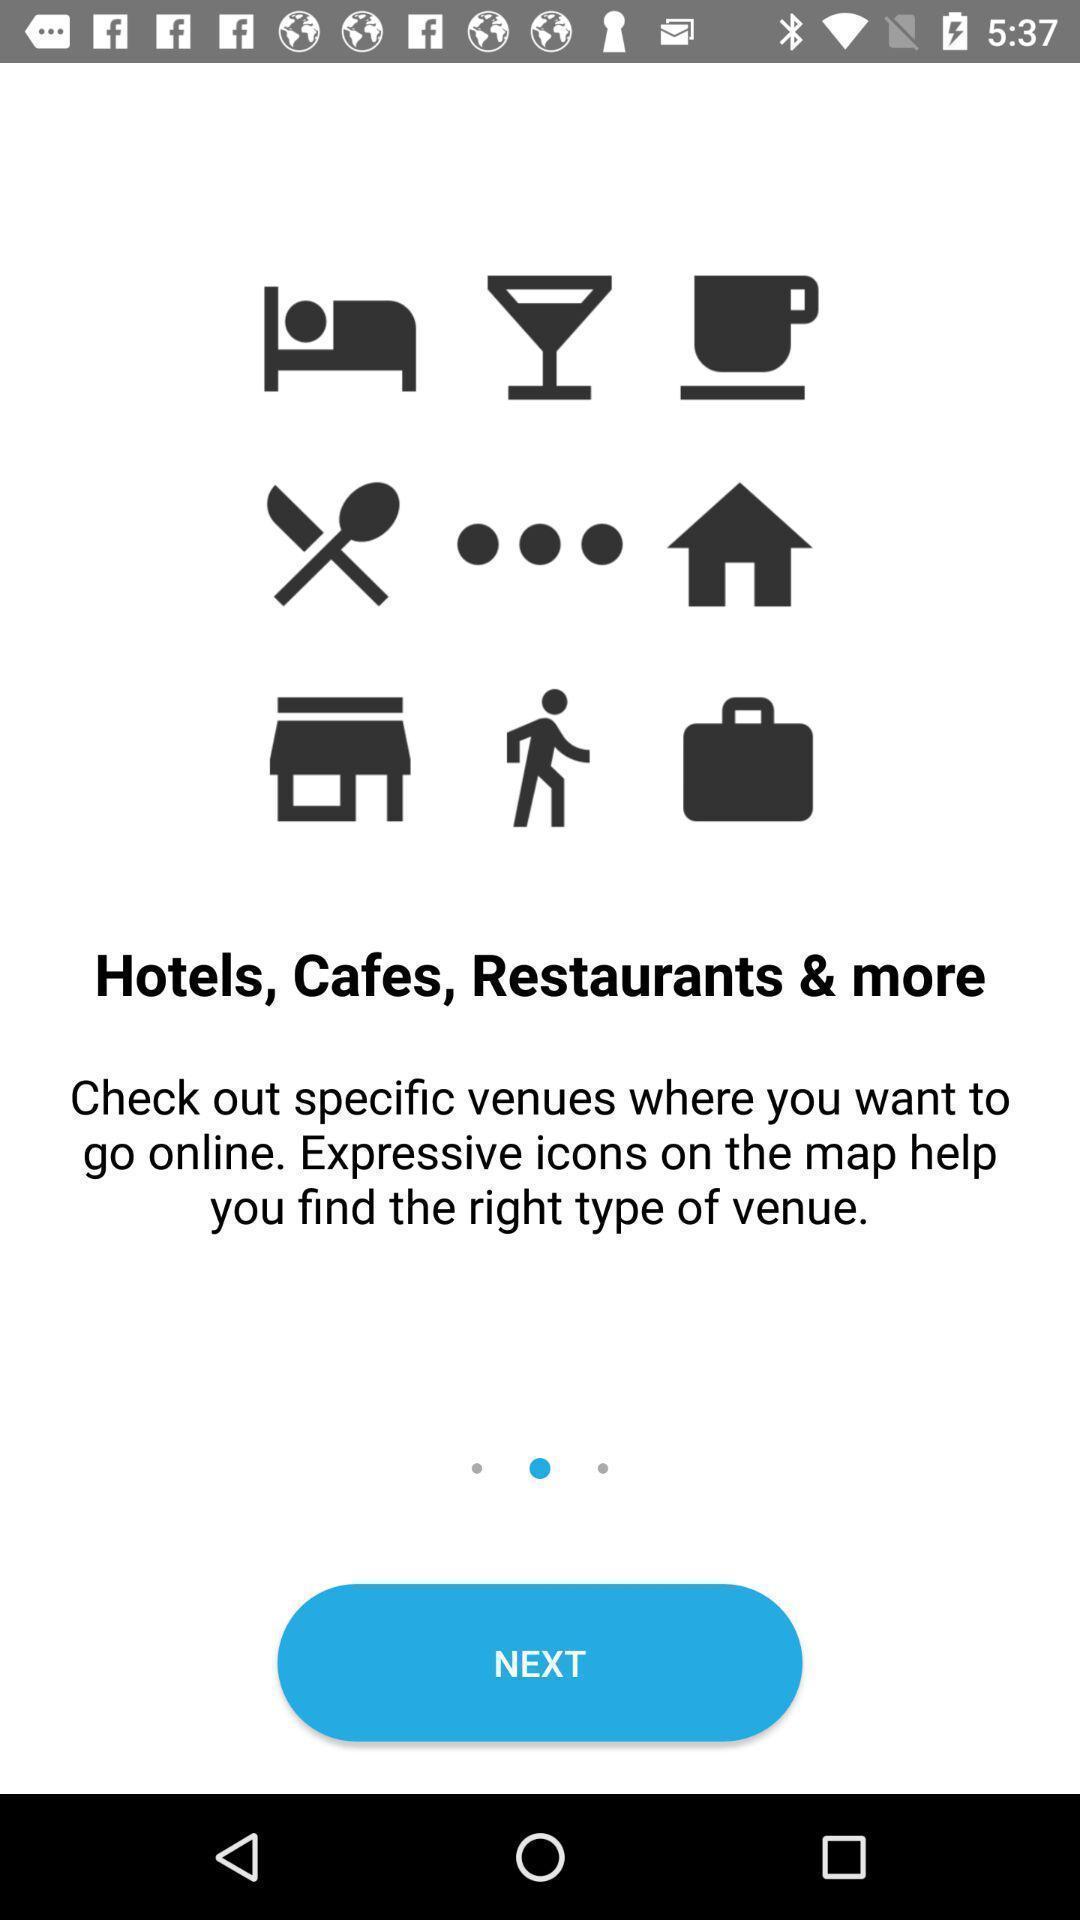Give me a narrative description of this picture. Page displaying information about a location finding application. 